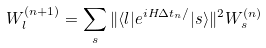Convert formula to latex. <formula><loc_0><loc_0><loc_500><loc_500>W _ { l } ^ { ( n + 1 ) } = \sum _ { s } \| \langle l | e ^ { i H \Delta t _ { n } / } | s \rangle \| ^ { 2 } W _ { s } ^ { ( n ) }</formula> 